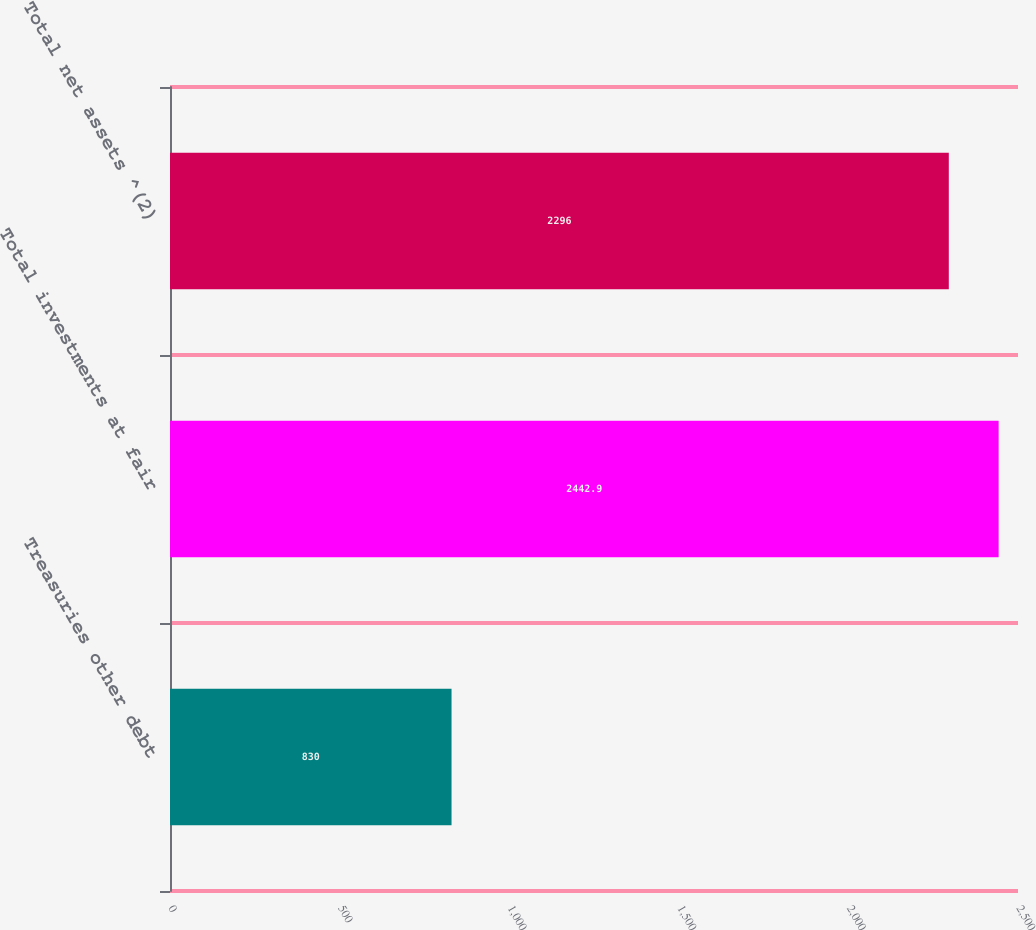<chart> <loc_0><loc_0><loc_500><loc_500><bar_chart><fcel>Treasuries other debt<fcel>Total investments at fair<fcel>Total net assets ^(2)<nl><fcel>830<fcel>2442.9<fcel>2296<nl></chart> 